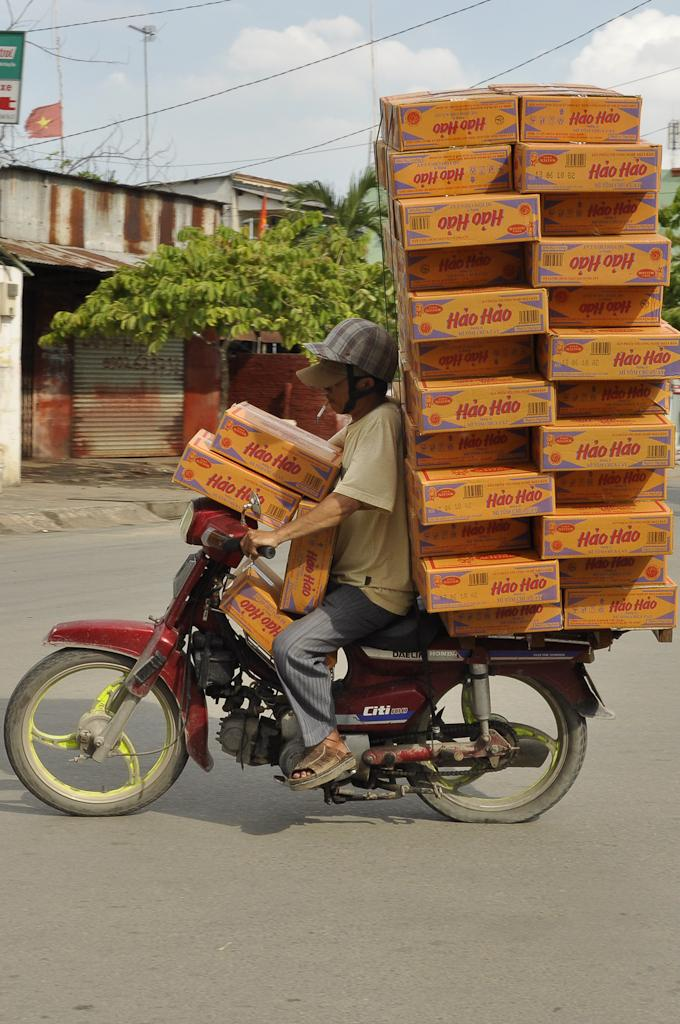What is the main feature of the image? There is a road in the image. What is the person on the road doing? A person is riding a motorbike. What is on the motorbike? There are boxes on the motorbike. What can be seen in the background of the image? There are buildings, trees, wires, and the sky visible in the background of the image. What type of disgust can be seen on the person's face while riding the motorbike? There is no indication of disgust on the person's face in the image. What type of steel is used to construct the buildings in the background? The image does not provide information about the materials used to construct the buildings in the background. 